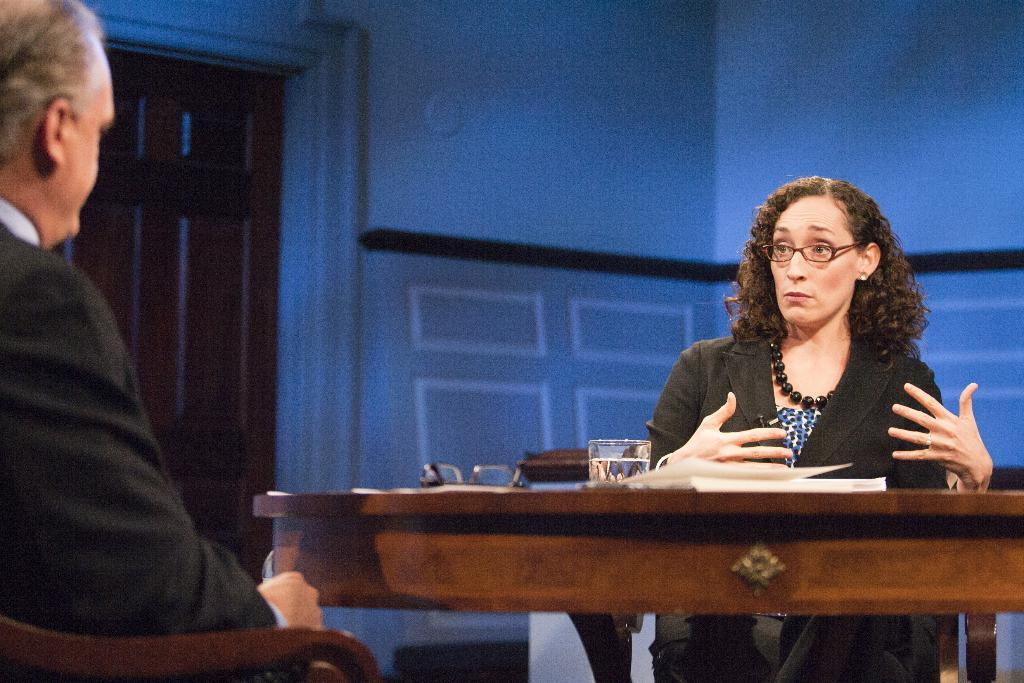Who can be seen in the image? There is a woman and a man in the image. What are the woman and man doing in the image? Both the woman and man are sitting on chairs. Where are the chairs located in relation to the table? The chairs are in front of a table. What can be seen on the table? There is a glass on the table, and there are other objects on the table as well. What type of cabbage is being served in the hospital during winter in the image? There is no hospital, winter, or cabbage present in the image. The image features a woman and a man sitting in front of a table with a glass and other objects. 